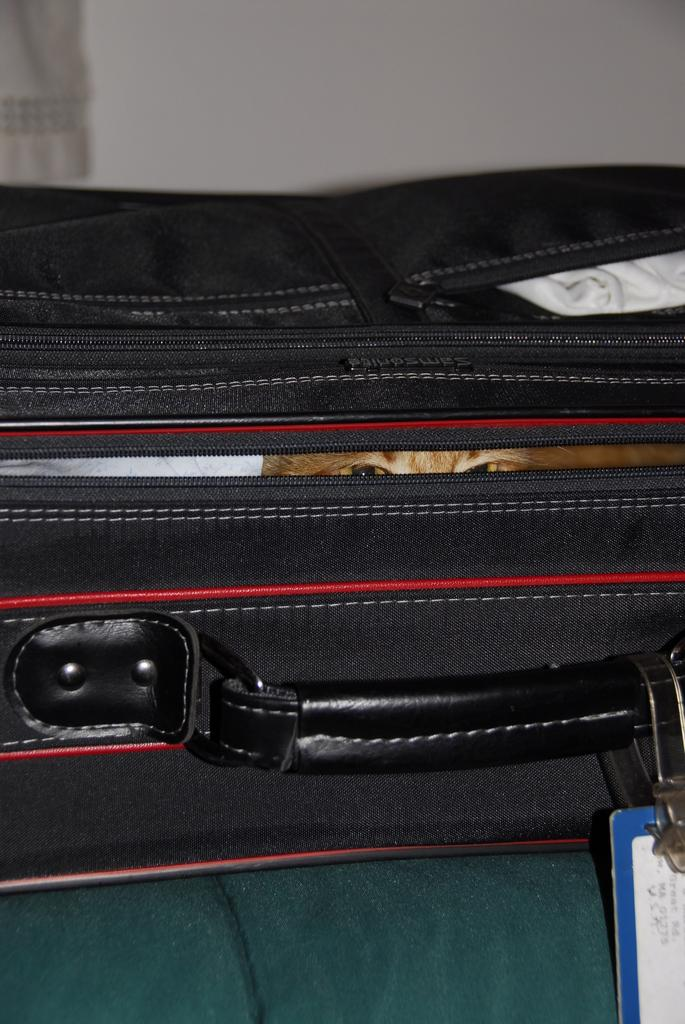What object is present in the image? There is a bag in the image. What is inside the bag? There is a cat in the bag. How many jellyfish are swimming in the oven in the image? There are no jellyfish or ovens present in the image. 